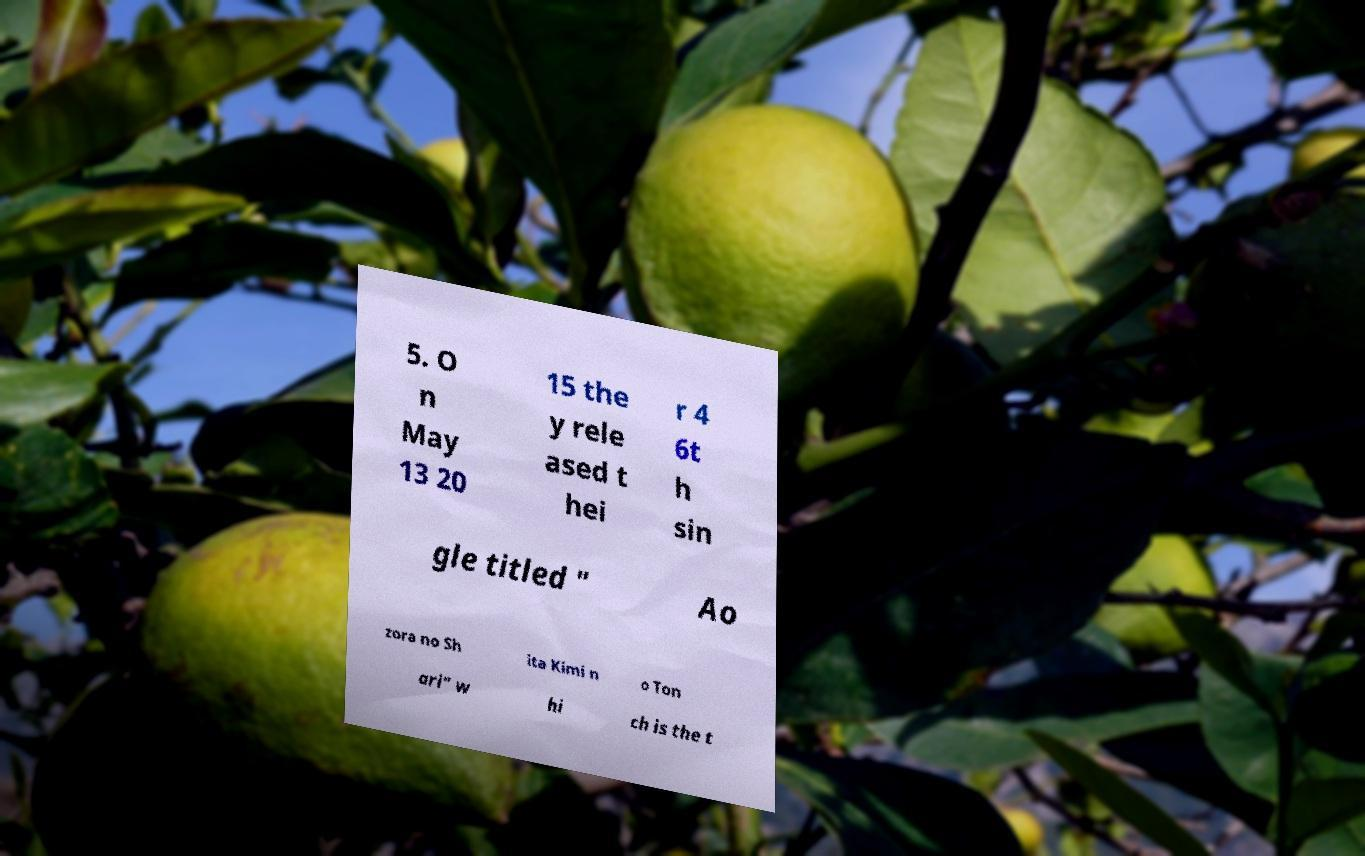Can you read and provide the text displayed in the image?This photo seems to have some interesting text. Can you extract and type it out for me? 5. O n May 13 20 15 the y rele ased t hei r 4 6t h sin gle titled " Ao zora no Sh ita Kimi n o Ton ari" w hi ch is the t 